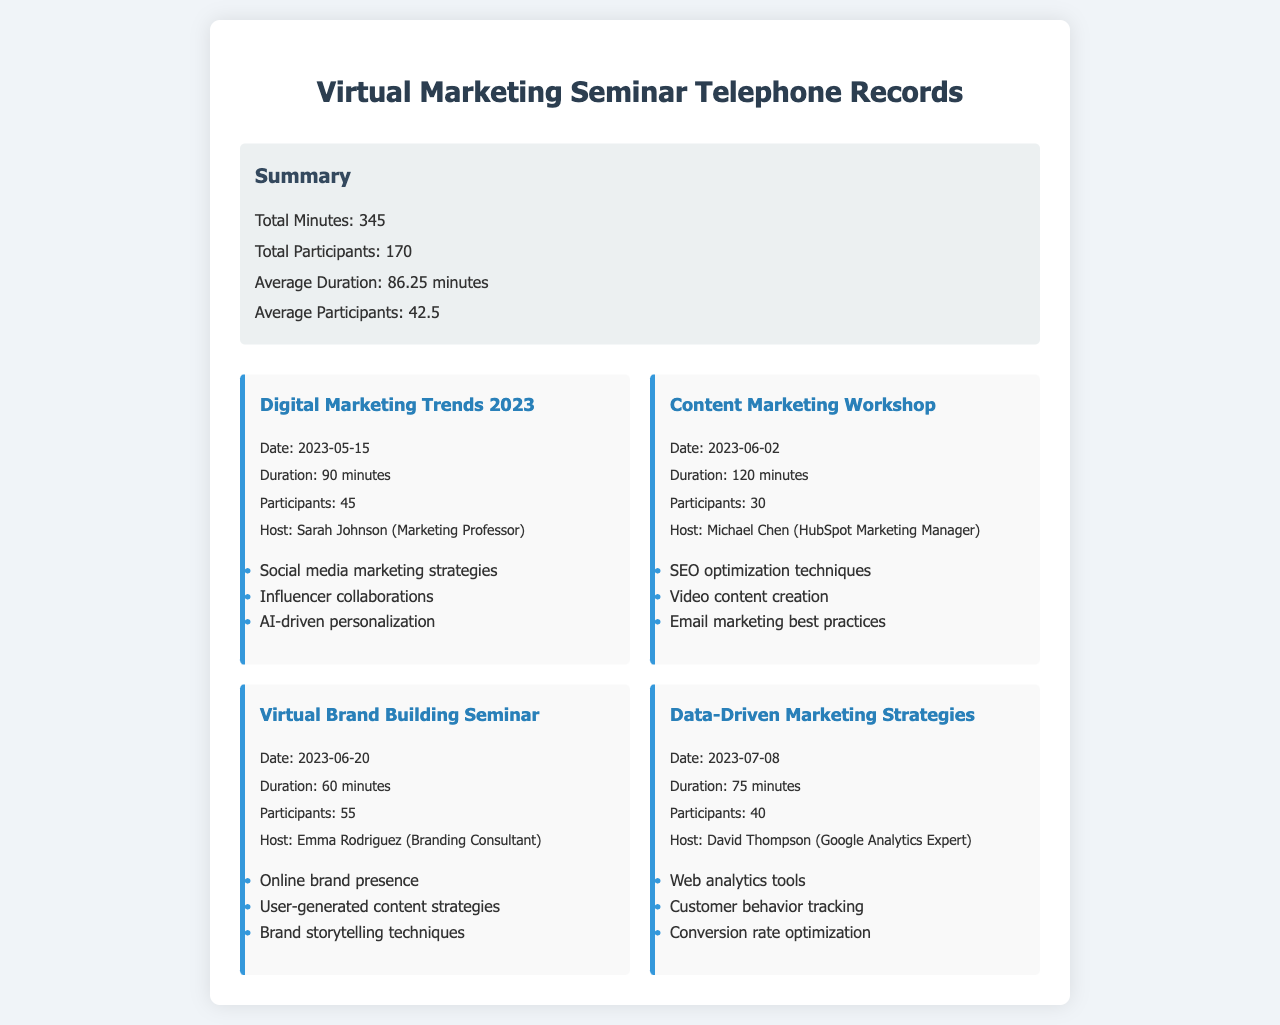What is the total duration of all calls? The total duration of all calls is detailed in the summary section of the document, stating "Total Minutes: 345."
Answer: 345 Who hosted the "Content Marketing Workshop"? The host is mentioned in the call record for the workshop, which states "Host: Michael Chen (HubSpot Marketing Manager)."
Answer: Michael Chen How many participants joined the "Virtual Brand Building Seminar"? The number of participants is provided in the call record for that seminar, which states "Participants: 55."
Answer: 55 What was the date of the "Digital Marketing Trends 2023" seminar? The date is specifically listed in the call record as "Date: 2023-05-15."
Answer: 2023-05-15 What is the average number of participants across all calls? The average number of participants is found in the summary section of the document, stating "Average Participants: 42.5."
Answer: 42.5 Which seminar lasted the longest? The durations of the seminars can be compared, and "Content Marketing Workshop" lasted the longest at "120 minutes."
Answer: Content Marketing Workshop What strategy is mentioned in the "Data-Driven Marketing Strategies"? A specific strategy is listed in the call record, mentioning "Customer behavior tracking."
Answer: Customer behavior tracking How many total participants attended all seminars? The total participants from all calls are summed up in the summary, stating "Total Participants: 170."
Answer: 170 What key point is associated with the "Digital Marketing Trends 2023"? One of the key points listed for that seminar is "AI-driven personalization."
Answer: AI-driven personalization 